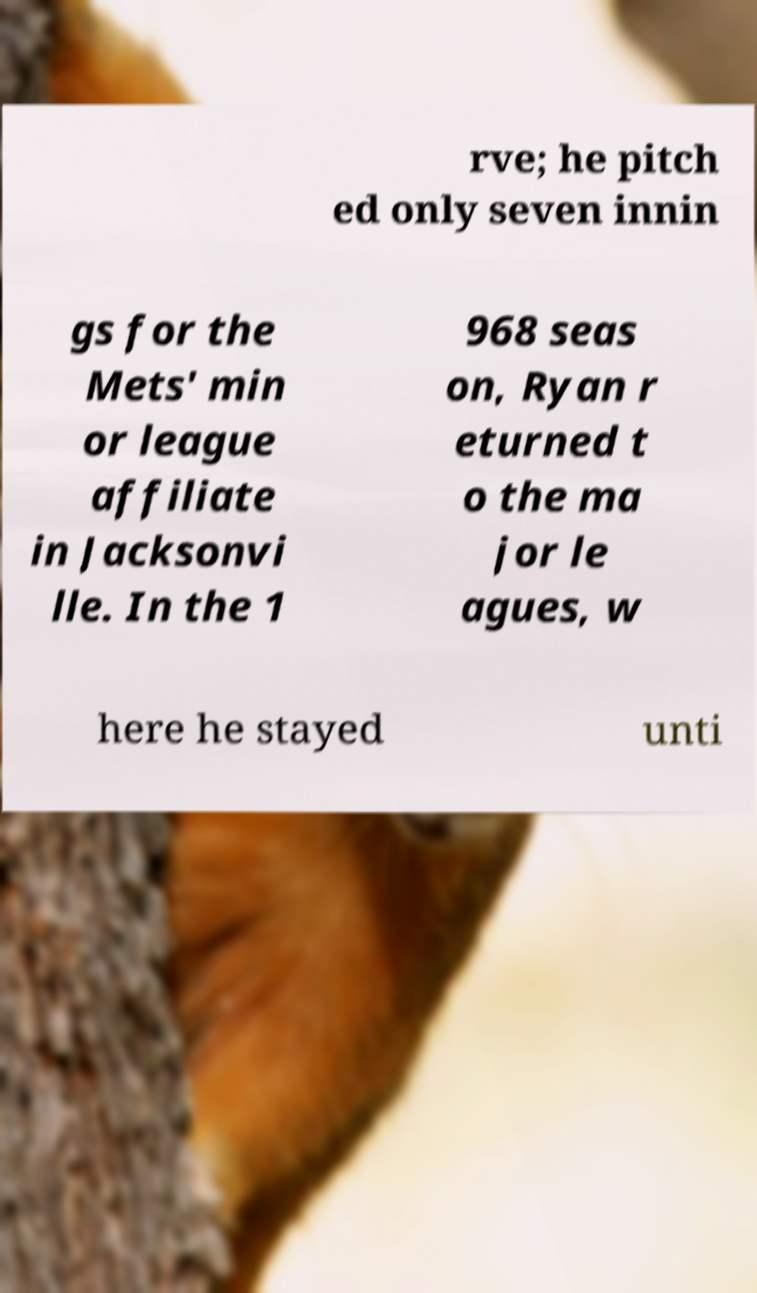Please read and relay the text visible in this image. What does it say? rve; he pitch ed only seven innin gs for the Mets' min or league affiliate in Jacksonvi lle. In the 1 968 seas on, Ryan r eturned t o the ma jor le agues, w here he stayed unti 